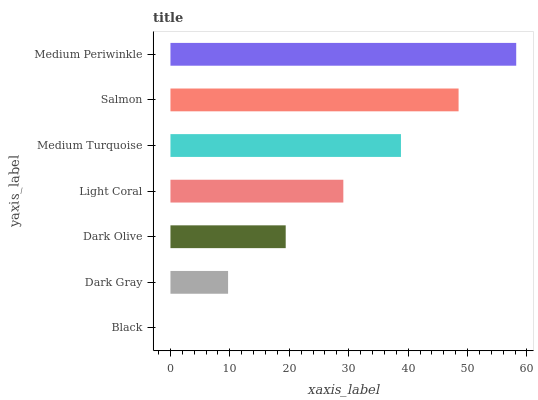Is Black the minimum?
Answer yes or no. Yes. Is Medium Periwinkle the maximum?
Answer yes or no. Yes. Is Dark Gray the minimum?
Answer yes or no. No. Is Dark Gray the maximum?
Answer yes or no. No. Is Dark Gray greater than Black?
Answer yes or no. Yes. Is Black less than Dark Gray?
Answer yes or no. Yes. Is Black greater than Dark Gray?
Answer yes or no. No. Is Dark Gray less than Black?
Answer yes or no. No. Is Light Coral the high median?
Answer yes or no. Yes. Is Light Coral the low median?
Answer yes or no. Yes. Is Dark Gray the high median?
Answer yes or no. No. Is Black the low median?
Answer yes or no. No. 